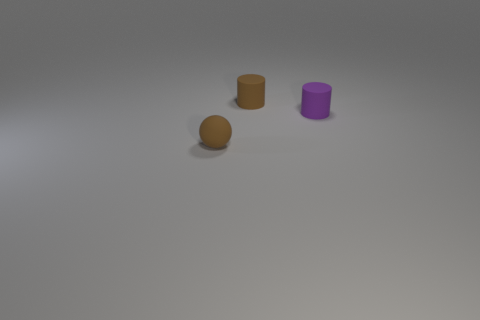Add 2 purple cylinders. How many objects exist? 5 Subtract 1 brown balls. How many objects are left? 2 Subtract all balls. How many objects are left? 2 Subtract all small red balls. Subtract all brown cylinders. How many objects are left? 2 Add 1 small brown matte cylinders. How many small brown matte cylinders are left? 2 Add 1 large blue rubber objects. How many large blue rubber objects exist? 1 